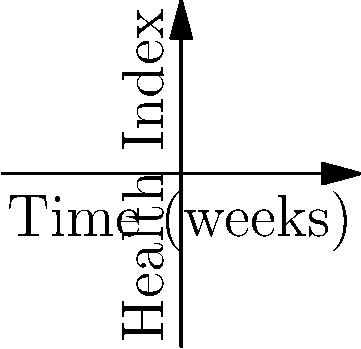In a study comparing two herbal treatments for arthritis in dogs, the health index of patients is modeled using non-Euclidean transformations. Treatment A follows the curve $f(x) = e^{-x^2/2}$, while Treatment B follows $g(x) = 1 - e^{-x^2/2}$, where $x$ represents time in weeks. After 1.5 weeks, what is the difference in health indices between treatments A and B? To solve this problem, we need to follow these steps:

1) First, we need to calculate the health index for Treatment A at 1.5 weeks:
   $f(1.5) = e^{-(1.5)^2/2} = e^{-1.125} \approx 0.3247$

2) Next, we calculate the health index for Treatment B at 1.5 weeks:
   $g(1.5) = 1 - e^{-(1.5)^2/2} = 1 - e^{-1.125} \approx 0.6753$

3) Now, we need to find the difference between these two values:
   Difference = $g(1.5) - f(1.5) = 0.6753 - 0.3247 = 0.3506$

4) This difference represents the gap between the two treatments' effectiveness after 1.5 weeks in the non-Euclidean space of the health index model.

5) The positive value indicates that Treatment B has a higher health index at this point in time.
Answer: 0.3506 